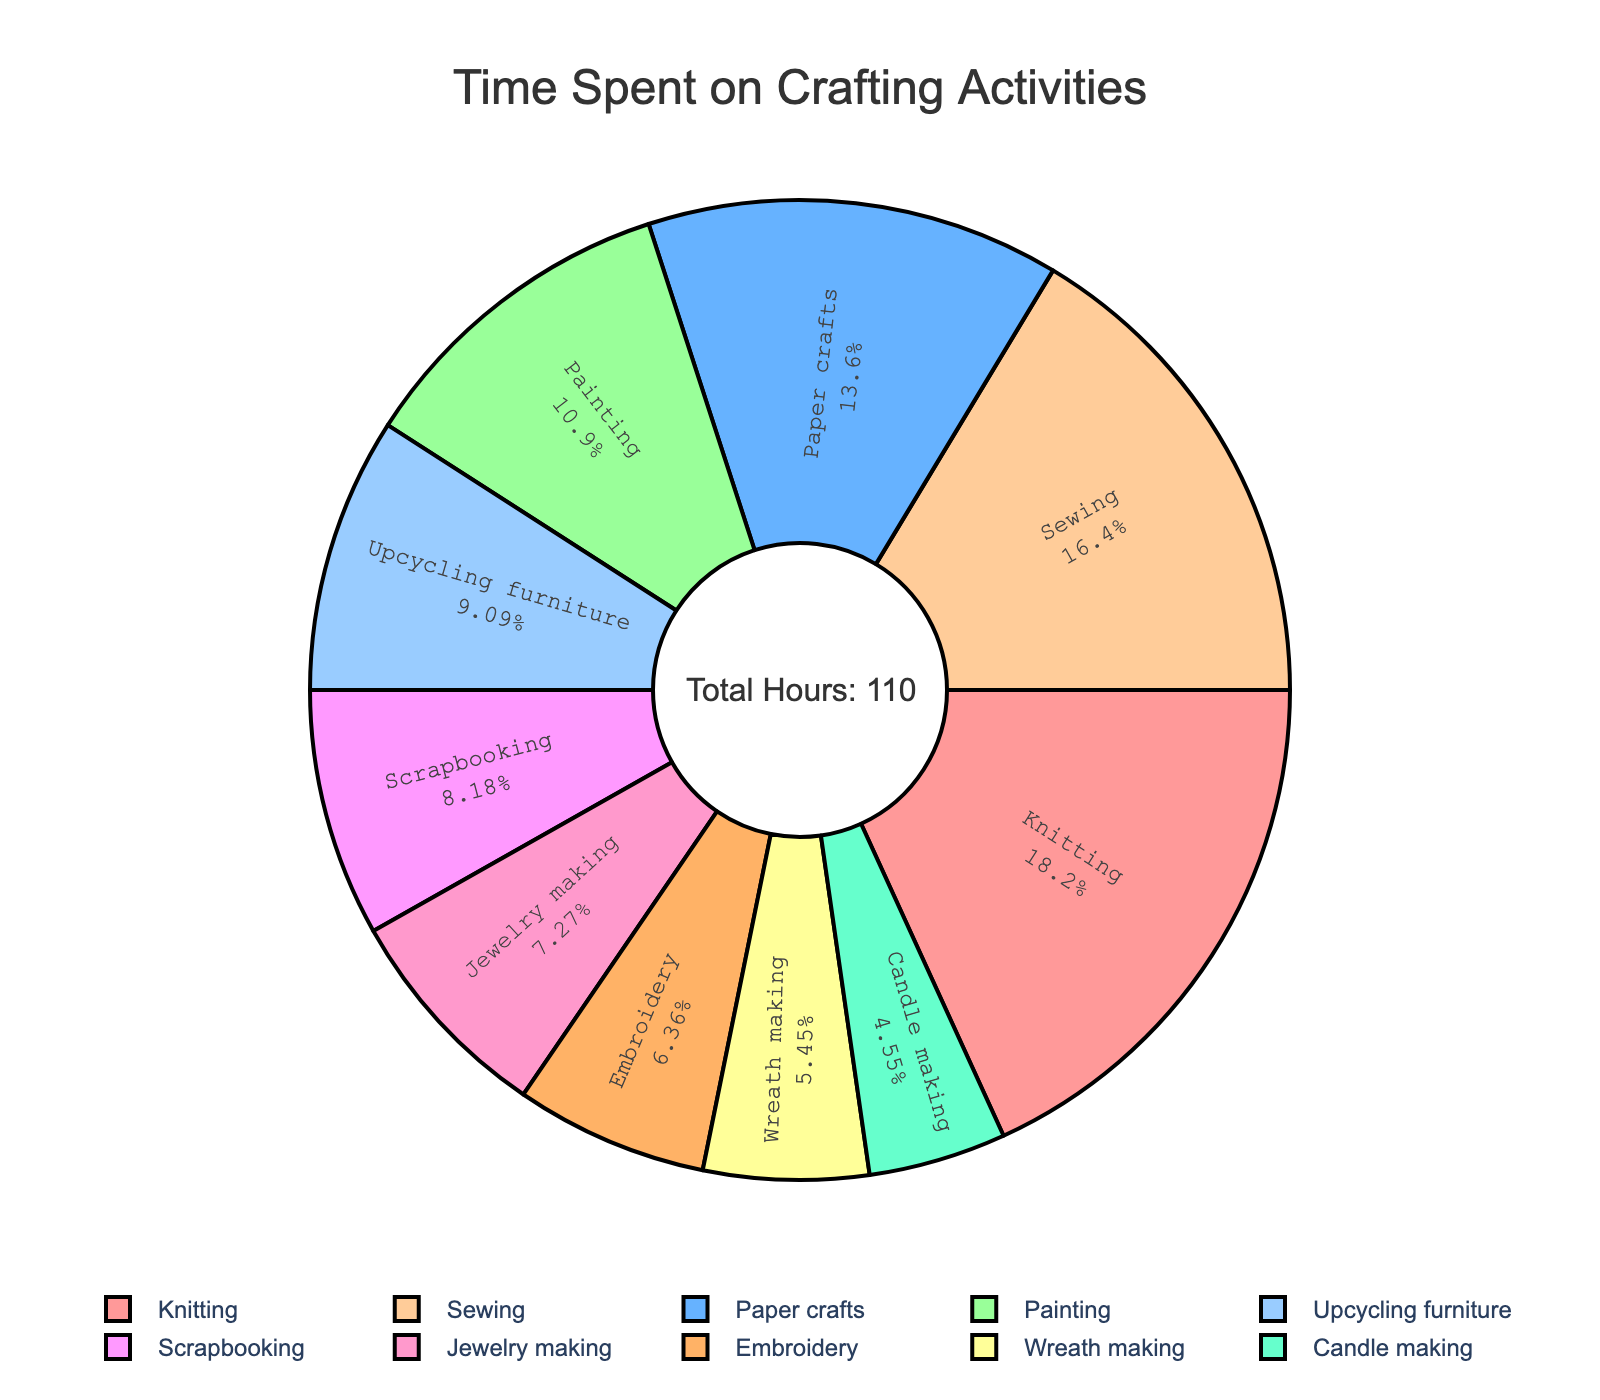What activity takes up the most time? Identify the segment of the pie chart with the largest percentage. The activity with the highest value is 20 hours for Knitting.
Answer: Knitting What is the total time spent on Sewing and Painting combined? Locate Sewing (18 hours) and Painting (12 hours) on the chart. Sum these values: 18 + 12 = 30 hours.
Answer: 30 hours Which activity has a larger share of time, Scrapbooking or Candle making? Compare the segments for Scrapbooking (9 hours) and Candle making (5 hours). Scrapbooking has a larger share.
Answer: Scrapbooking Which color represents Jewelry making? Observe the color coding on the pie chart. Jewelry making is represented by light pink.
Answer: Light pink How much more time is spent on Knitting than on Embroidery? Find Knitting (20 hours) and Embroidery (7 hours). Subtract Embroidery from Knitting: 20 - 7 = 13 hours.
Answer: 13 hours What percentage of time is spent on Paper crafts? Look for the Paper crafts segment and check its percentage. It represents 15 hours out of 110 total hours: (15/110) * 100 ≈ 13.64%.
Answer: 13.64% Which activities have a time allocation less than 10 hours? Identify segments with values less than 10 hours: Jewelry making (8 hours), Wreath making (6 hours), Candle making (5 hours), and Embroidery (7 hours).
Answer: Jewelry making, Wreath making, Candle making, Embroidery What is the average time spent on all activities? Sum all activity hours (110 hours) and divide by the number of activities (10): 110/10 = 11 hours.
Answer: 11 hours How much time is spent on Upcycling furniture compared to Wreath making? Upcycling furniture takes 10 hours while Wreath making takes 6 hours. Compare these values: 10 is greater than 6.
Answer: Upcycling furniture takes more time What is the total percentage of time spent on Knitting, Sewing, and Painting together? Sum the hours for Knitting (20), Sewing (18), and Painting (12): 20 + 18 + 12 = 50 hours. Calculate the percentage: (50/110) * 100 ≈ 45.45%.
Answer: 45.45% 